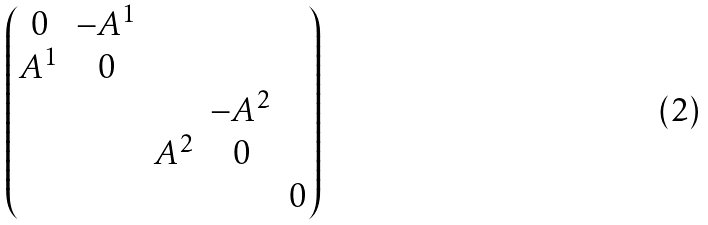Convert formula to latex. <formula><loc_0><loc_0><loc_500><loc_500>\begin{pmatrix} 0 & - A ^ { 1 } & & & \\ A ^ { 1 } & 0 & & & \\ & & & - A ^ { 2 } & \\ & & A ^ { 2 } & 0 & \\ & & & & 0 \end{pmatrix}</formula> 